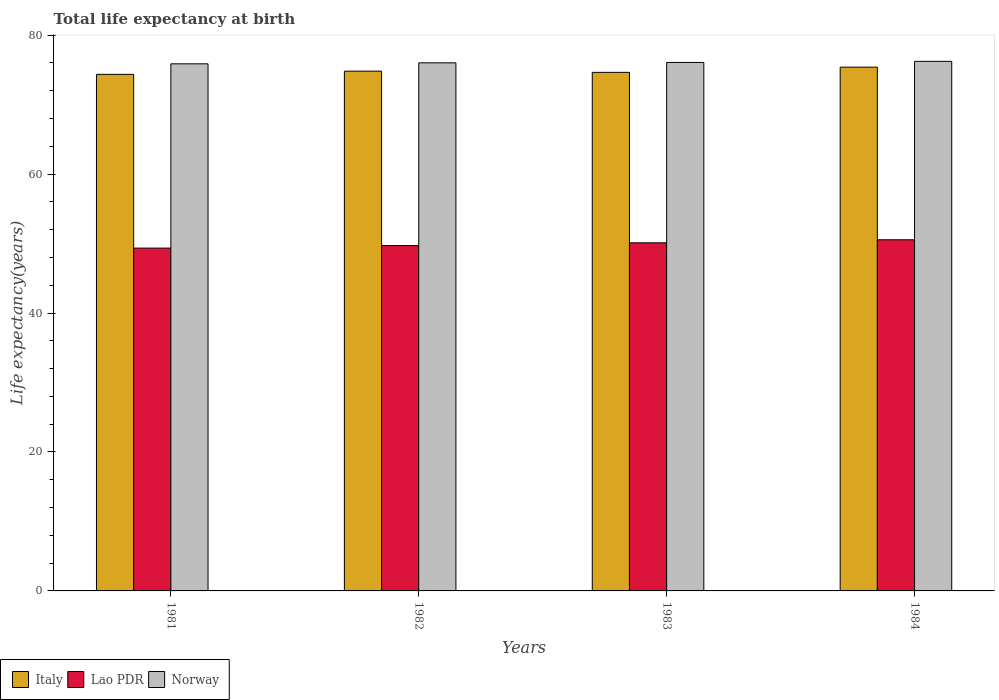How many groups of bars are there?
Make the answer very short. 4. Are the number of bars per tick equal to the number of legend labels?
Provide a succinct answer. Yes. How many bars are there on the 1st tick from the left?
Provide a short and direct response. 3. How many bars are there on the 4th tick from the right?
Your answer should be very brief. 3. What is the label of the 2nd group of bars from the left?
Make the answer very short. 1982. What is the life expectancy at birth in in Italy in 1984?
Provide a short and direct response. 75.39. Across all years, what is the maximum life expectancy at birth in in Norway?
Provide a succinct answer. 76.22. Across all years, what is the minimum life expectancy at birth in in Lao PDR?
Keep it short and to the point. 49.34. In which year was the life expectancy at birth in in Norway maximum?
Make the answer very short. 1984. What is the total life expectancy at birth in in Italy in the graph?
Provide a succinct answer. 299.2. What is the difference between the life expectancy at birth in in Lao PDR in 1982 and that in 1983?
Provide a short and direct response. -0.4. What is the difference between the life expectancy at birth in in Italy in 1981 and the life expectancy at birth in in Norway in 1983?
Provide a succinct answer. -1.71. What is the average life expectancy at birth in in Lao PDR per year?
Your response must be concise. 49.92. In the year 1982, what is the difference between the life expectancy at birth in in Lao PDR and life expectancy at birth in in Italy?
Make the answer very short. -25.11. In how many years, is the life expectancy at birth in in Norway greater than 16 years?
Offer a very short reply. 4. What is the ratio of the life expectancy at birth in in Norway in 1981 to that in 1984?
Provide a succinct answer. 1. What is the difference between the highest and the second highest life expectancy at birth in in Norway?
Give a very brief answer. 0.16. What is the difference between the highest and the lowest life expectancy at birth in in Lao PDR?
Offer a very short reply. 1.2. In how many years, is the life expectancy at birth in in Italy greater than the average life expectancy at birth in in Italy taken over all years?
Ensure brevity in your answer.  2. What does the 1st bar from the left in 1984 represents?
Give a very brief answer. Italy. What does the 3rd bar from the right in 1981 represents?
Offer a very short reply. Italy. Is it the case that in every year, the sum of the life expectancy at birth in in Lao PDR and life expectancy at birth in in Italy is greater than the life expectancy at birth in in Norway?
Your answer should be compact. Yes. How many bars are there?
Your response must be concise. 12. Are all the bars in the graph horizontal?
Ensure brevity in your answer.  No. Where does the legend appear in the graph?
Provide a succinct answer. Bottom left. What is the title of the graph?
Your response must be concise. Total life expectancy at birth. Does "Low income" appear as one of the legend labels in the graph?
Provide a succinct answer. No. What is the label or title of the Y-axis?
Your answer should be very brief. Life expectancy(years). What is the Life expectancy(years) of Italy in 1981?
Your answer should be compact. 74.35. What is the Life expectancy(years) in Lao PDR in 1981?
Provide a short and direct response. 49.34. What is the Life expectancy(years) of Norway in 1981?
Offer a very short reply. 75.87. What is the Life expectancy(years) in Italy in 1982?
Your answer should be very brief. 74.81. What is the Life expectancy(years) in Lao PDR in 1982?
Your answer should be compact. 49.7. What is the Life expectancy(years) of Norway in 1982?
Offer a terse response. 76.01. What is the Life expectancy(years) in Italy in 1983?
Offer a very short reply. 74.64. What is the Life expectancy(years) in Lao PDR in 1983?
Make the answer very short. 50.1. What is the Life expectancy(years) of Norway in 1983?
Offer a very short reply. 76.07. What is the Life expectancy(years) in Italy in 1984?
Provide a short and direct response. 75.39. What is the Life expectancy(years) in Lao PDR in 1984?
Give a very brief answer. 50.54. What is the Life expectancy(years) in Norway in 1984?
Give a very brief answer. 76.22. Across all years, what is the maximum Life expectancy(years) of Italy?
Your response must be concise. 75.39. Across all years, what is the maximum Life expectancy(years) in Lao PDR?
Your response must be concise. 50.54. Across all years, what is the maximum Life expectancy(years) of Norway?
Provide a short and direct response. 76.22. Across all years, what is the minimum Life expectancy(years) of Italy?
Make the answer very short. 74.35. Across all years, what is the minimum Life expectancy(years) in Lao PDR?
Offer a terse response. 49.34. Across all years, what is the minimum Life expectancy(years) of Norway?
Ensure brevity in your answer.  75.87. What is the total Life expectancy(years) in Italy in the graph?
Provide a succinct answer. 299.2. What is the total Life expectancy(years) of Lao PDR in the graph?
Keep it short and to the point. 199.7. What is the total Life expectancy(years) in Norway in the graph?
Keep it short and to the point. 304.17. What is the difference between the Life expectancy(years) in Italy in 1981 and that in 1982?
Offer a terse response. -0.46. What is the difference between the Life expectancy(years) in Lao PDR in 1981 and that in 1982?
Give a very brief answer. -0.36. What is the difference between the Life expectancy(years) of Norway in 1981 and that in 1982?
Make the answer very short. -0.14. What is the difference between the Life expectancy(years) in Italy in 1981 and that in 1983?
Provide a succinct answer. -0.29. What is the difference between the Life expectancy(years) of Lao PDR in 1981 and that in 1983?
Make the answer very short. -0.76. What is the difference between the Life expectancy(years) of Norway in 1981 and that in 1983?
Your response must be concise. -0.2. What is the difference between the Life expectancy(years) of Italy in 1981 and that in 1984?
Offer a very short reply. -1.04. What is the difference between the Life expectancy(years) of Lao PDR in 1981 and that in 1984?
Your answer should be very brief. -1.2. What is the difference between the Life expectancy(years) of Norway in 1981 and that in 1984?
Provide a succinct answer. -0.36. What is the difference between the Life expectancy(years) of Italy in 1982 and that in 1983?
Your answer should be compact. 0.17. What is the difference between the Life expectancy(years) in Lao PDR in 1982 and that in 1983?
Your answer should be compact. -0.4. What is the difference between the Life expectancy(years) of Norway in 1982 and that in 1983?
Give a very brief answer. -0.06. What is the difference between the Life expectancy(years) in Italy in 1982 and that in 1984?
Offer a very short reply. -0.57. What is the difference between the Life expectancy(years) in Lao PDR in 1982 and that in 1984?
Provide a succinct answer. -0.84. What is the difference between the Life expectancy(years) of Norway in 1982 and that in 1984?
Your answer should be very brief. -0.21. What is the difference between the Life expectancy(years) of Italy in 1983 and that in 1984?
Make the answer very short. -0.75. What is the difference between the Life expectancy(years) of Lao PDR in 1983 and that in 1984?
Your response must be concise. -0.44. What is the difference between the Life expectancy(years) in Norway in 1983 and that in 1984?
Provide a succinct answer. -0.16. What is the difference between the Life expectancy(years) of Italy in 1981 and the Life expectancy(years) of Lao PDR in 1982?
Your answer should be compact. 24.65. What is the difference between the Life expectancy(years) in Italy in 1981 and the Life expectancy(years) in Norway in 1982?
Keep it short and to the point. -1.66. What is the difference between the Life expectancy(years) in Lao PDR in 1981 and the Life expectancy(years) in Norway in 1982?
Offer a very short reply. -26.67. What is the difference between the Life expectancy(years) in Italy in 1981 and the Life expectancy(years) in Lao PDR in 1983?
Your response must be concise. 24.25. What is the difference between the Life expectancy(years) of Italy in 1981 and the Life expectancy(years) of Norway in 1983?
Offer a very short reply. -1.71. What is the difference between the Life expectancy(years) in Lao PDR in 1981 and the Life expectancy(years) in Norway in 1983?
Offer a very short reply. -26.72. What is the difference between the Life expectancy(years) of Italy in 1981 and the Life expectancy(years) of Lao PDR in 1984?
Ensure brevity in your answer.  23.81. What is the difference between the Life expectancy(years) of Italy in 1981 and the Life expectancy(years) of Norway in 1984?
Keep it short and to the point. -1.87. What is the difference between the Life expectancy(years) in Lao PDR in 1981 and the Life expectancy(years) in Norway in 1984?
Give a very brief answer. -26.88. What is the difference between the Life expectancy(years) in Italy in 1982 and the Life expectancy(years) in Lao PDR in 1983?
Make the answer very short. 24.71. What is the difference between the Life expectancy(years) in Italy in 1982 and the Life expectancy(years) in Norway in 1983?
Give a very brief answer. -1.25. What is the difference between the Life expectancy(years) of Lao PDR in 1982 and the Life expectancy(years) of Norway in 1983?
Keep it short and to the point. -26.36. What is the difference between the Life expectancy(years) of Italy in 1982 and the Life expectancy(years) of Lao PDR in 1984?
Offer a very short reply. 24.27. What is the difference between the Life expectancy(years) of Italy in 1982 and the Life expectancy(years) of Norway in 1984?
Your response must be concise. -1.41. What is the difference between the Life expectancy(years) in Lao PDR in 1982 and the Life expectancy(years) in Norway in 1984?
Provide a short and direct response. -26.52. What is the difference between the Life expectancy(years) in Italy in 1983 and the Life expectancy(years) in Lao PDR in 1984?
Make the answer very short. 24.1. What is the difference between the Life expectancy(years) of Italy in 1983 and the Life expectancy(years) of Norway in 1984?
Offer a very short reply. -1.58. What is the difference between the Life expectancy(years) in Lao PDR in 1983 and the Life expectancy(years) in Norway in 1984?
Make the answer very short. -26.12. What is the average Life expectancy(years) in Italy per year?
Your answer should be compact. 74.8. What is the average Life expectancy(years) in Lao PDR per year?
Your response must be concise. 49.92. What is the average Life expectancy(years) in Norway per year?
Your answer should be compact. 76.04. In the year 1981, what is the difference between the Life expectancy(years) in Italy and Life expectancy(years) in Lao PDR?
Your response must be concise. 25.01. In the year 1981, what is the difference between the Life expectancy(years) of Italy and Life expectancy(years) of Norway?
Ensure brevity in your answer.  -1.52. In the year 1981, what is the difference between the Life expectancy(years) in Lao PDR and Life expectancy(years) in Norway?
Your answer should be very brief. -26.52. In the year 1982, what is the difference between the Life expectancy(years) in Italy and Life expectancy(years) in Lao PDR?
Your answer should be compact. 25.11. In the year 1982, what is the difference between the Life expectancy(years) in Italy and Life expectancy(years) in Norway?
Provide a succinct answer. -1.2. In the year 1982, what is the difference between the Life expectancy(years) of Lao PDR and Life expectancy(years) of Norway?
Provide a short and direct response. -26.31. In the year 1983, what is the difference between the Life expectancy(years) in Italy and Life expectancy(years) in Lao PDR?
Provide a short and direct response. 24.54. In the year 1983, what is the difference between the Life expectancy(years) in Italy and Life expectancy(years) in Norway?
Offer a terse response. -1.43. In the year 1983, what is the difference between the Life expectancy(years) of Lao PDR and Life expectancy(years) of Norway?
Give a very brief answer. -25.96. In the year 1984, what is the difference between the Life expectancy(years) in Italy and Life expectancy(years) in Lao PDR?
Offer a terse response. 24.85. In the year 1984, what is the difference between the Life expectancy(years) of Italy and Life expectancy(years) of Norway?
Give a very brief answer. -0.83. In the year 1984, what is the difference between the Life expectancy(years) in Lao PDR and Life expectancy(years) in Norway?
Provide a succinct answer. -25.68. What is the ratio of the Life expectancy(years) of Norway in 1981 to that in 1982?
Make the answer very short. 1. What is the ratio of the Life expectancy(years) of Italy in 1981 to that in 1984?
Ensure brevity in your answer.  0.99. What is the ratio of the Life expectancy(years) in Lao PDR in 1981 to that in 1984?
Make the answer very short. 0.98. What is the ratio of the Life expectancy(years) in Lao PDR in 1982 to that in 1984?
Offer a very short reply. 0.98. What is the ratio of the Life expectancy(years) in Norway in 1982 to that in 1984?
Your answer should be very brief. 1. What is the difference between the highest and the second highest Life expectancy(years) of Italy?
Provide a short and direct response. 0.57. What is the difference between the highest and the second highest Life expectancy(years) of Lao PDR?
Offer a very short reply. 0.44. What is the difference between the highest and the second highest Life expectancy(years) of Norway?
Ensure brevity in your answer.  0.16. What is the difference between the highest and the lowest Life expectancy(years) of Italy?
Ensure brevity in your answer.  1.04. What is the difference between the highest and the lowest Life expectancy(years) in Lao PDR?
Your response must be concise. 1.2. What is the difference between the highest and the lowest Life expectancy(years) of Norway?
Provide a short and direct response. 0.36. 